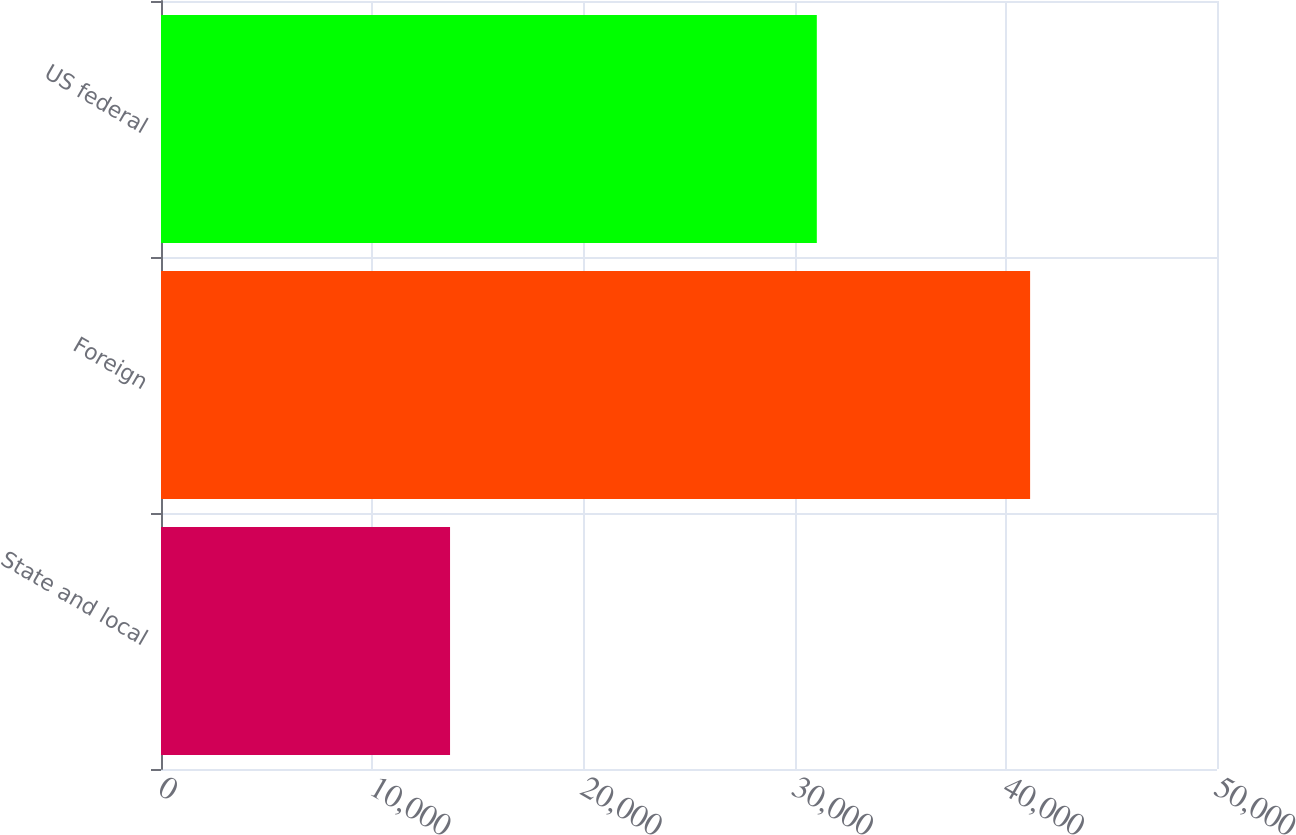<chart> <loc_0><loc_0><loc_500><loc_500><bar_chart><fcel>State and local<fcel>Foreign<fcel>US federal<nl><fcel>13686<fcel>41151<fcel>31052<nl></chart> 